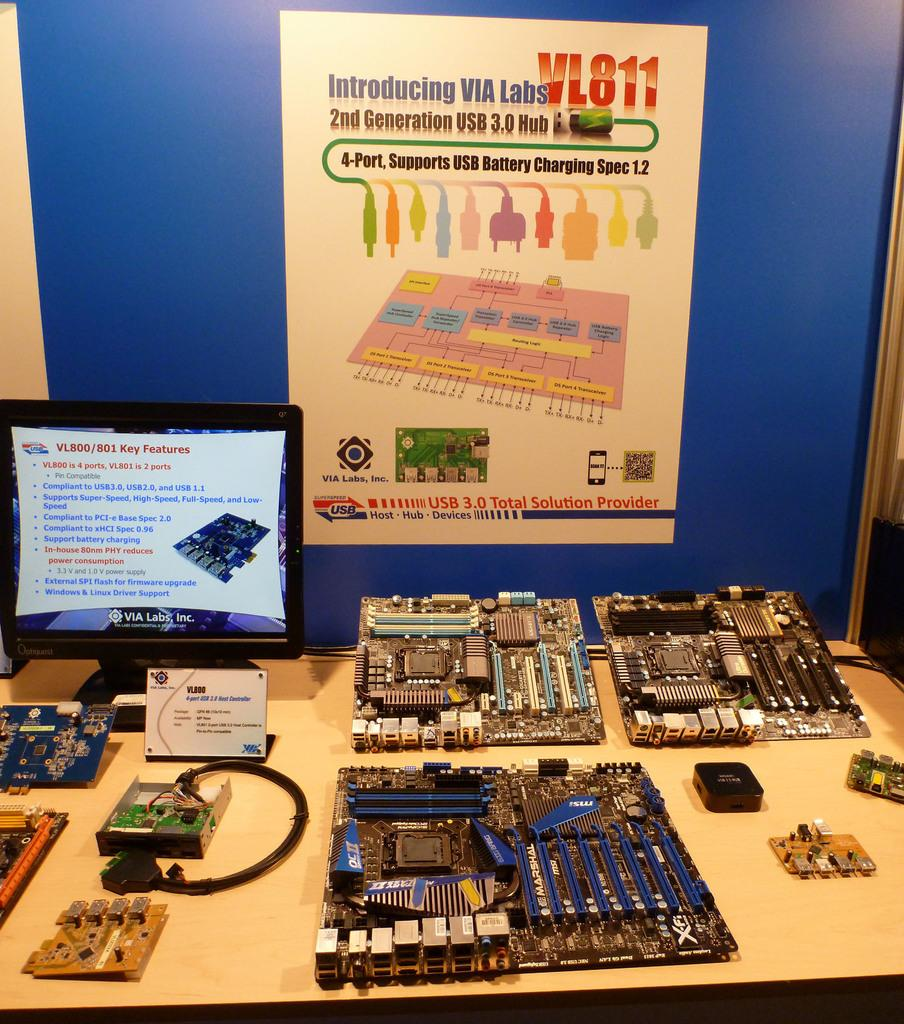Provide a one-sentence caption for the provided image. A poster hanging above a table full of electronic components is introducing the new VL811 Hub. 